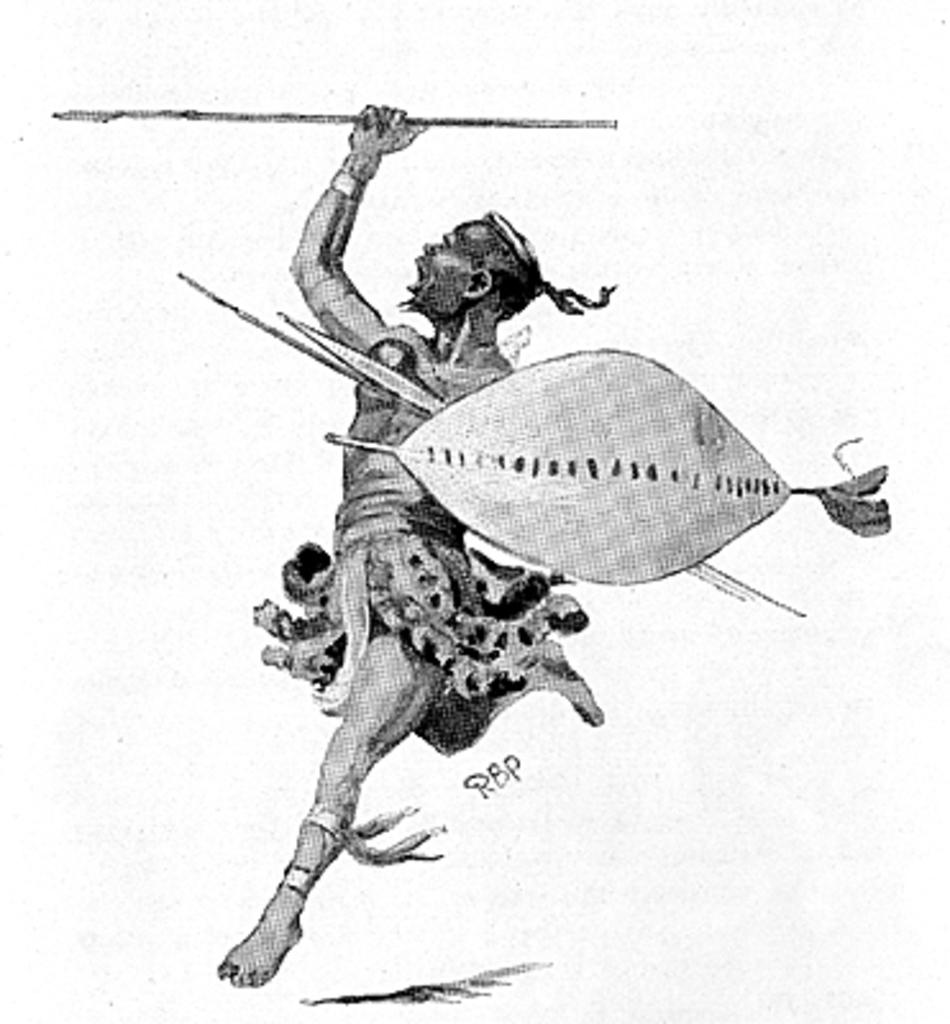What is the main subject of the image? There is a painting in the image. What does the painting depict? The painting depicts a person. How far away is the chicken from the person in the painting? There is no chicken present in the painting, so it cannot be determined how far away it would be from the person. 